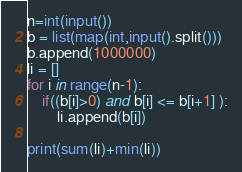<code> <loc_0><loc_0><loc_500><loc_500><_Python_>n=int(input())
b = list(map(int,input().split()))
b.append(1000000)
li = []
for i in range(n-1):
    if((b[i]>0) and b[i] <= b[i+1] ):
        li.append(b[i])

print(sum(li)+min(li))</code> 